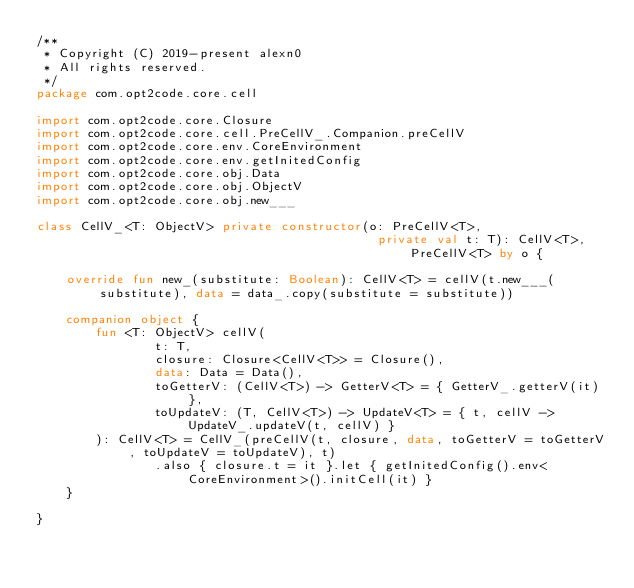Convert code to text. <code><loc_0><loc_0><loc_500><loc_500><_Kotlin_>/**
 * Copyright (C) 2019-present alexn0
 * All rights reserved.
 */
package com.opt2code.core.cell

import com.opt2code.core.Closure
import com.opt2code.core.cell.PreCellV_.Companion.preCellV
import com.opt2code.core.env.CoreEnvironment
import com.opt2code.core.env.getInitedConfig
import com.opt2code.core.obj.Data
import com.opt2code.core.obj.ObjectV
import com.opt2code.core.obj.new___

class CellV_<T: ObjectV> private constructor(o: PreCellV<T>,
                                              private val t: T): CellV<T>, PreCellV<T> by o {

    override fun new_(substitute: Boolean): CellV<T> = cellV(t.new___(substitute), data = data_.copy(substitute = substitute))

    companion object {
        fun <T: ObjectV> cellV(
                t: T,
                closure: Closure<CellV<T>> = Closure(),
                data: Data = Data(),
                toGetterV: (CellV<T>) -> GetterV<T> = { GetterV_.getterV(it) },
                toUpdateV: (T, CellV<T>) -> UpdateV<T> = { t, cellV -> UpdateV_.updateV(t, cellV) }
        ): CellV<T> = CellV_(preCellV(t, closure, data, toGetterV = toGetterV, toUpdateV = toUpdateV), t)
                .also { closure.t = it }.let { getInitedConfig().env<CoreEnvironment>().initCell(it) }
    }

}</code> 